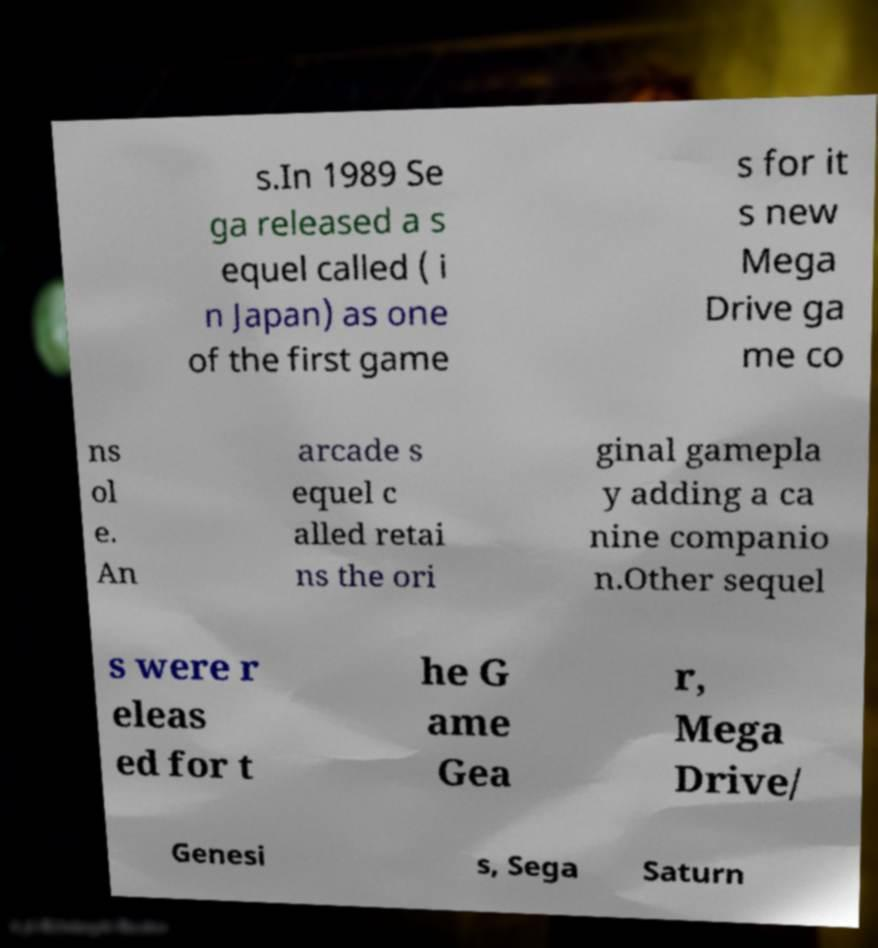Could you extract and type out the text from this image? s.In 1989 Se ga released a s equel called ( i n Japan) as one of the first game s for it s new Mega Drive ga me co ns ol e. An arcade s equel c alled retai ns the ori ginal gamepla y adding a ca nine companio n.Other sequel s were r eleas ed for t he G ame Gea r, Mega Drive/ Genesi s, Sega Saturn 